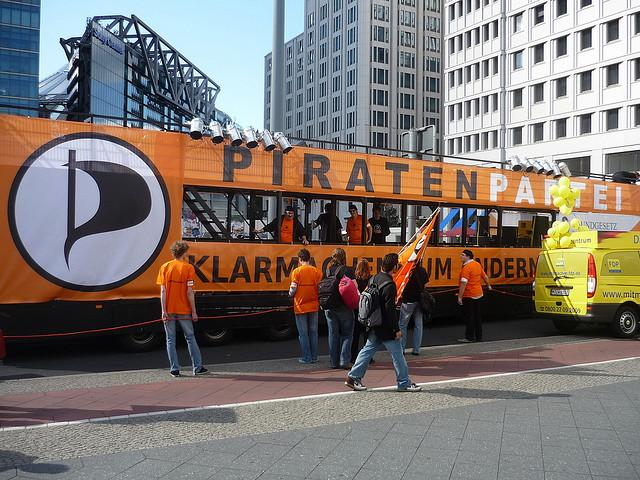What fun item can be seen in the photo?

Choices:
A) ponies
B) candy
C) rides
D) balloons balloons 